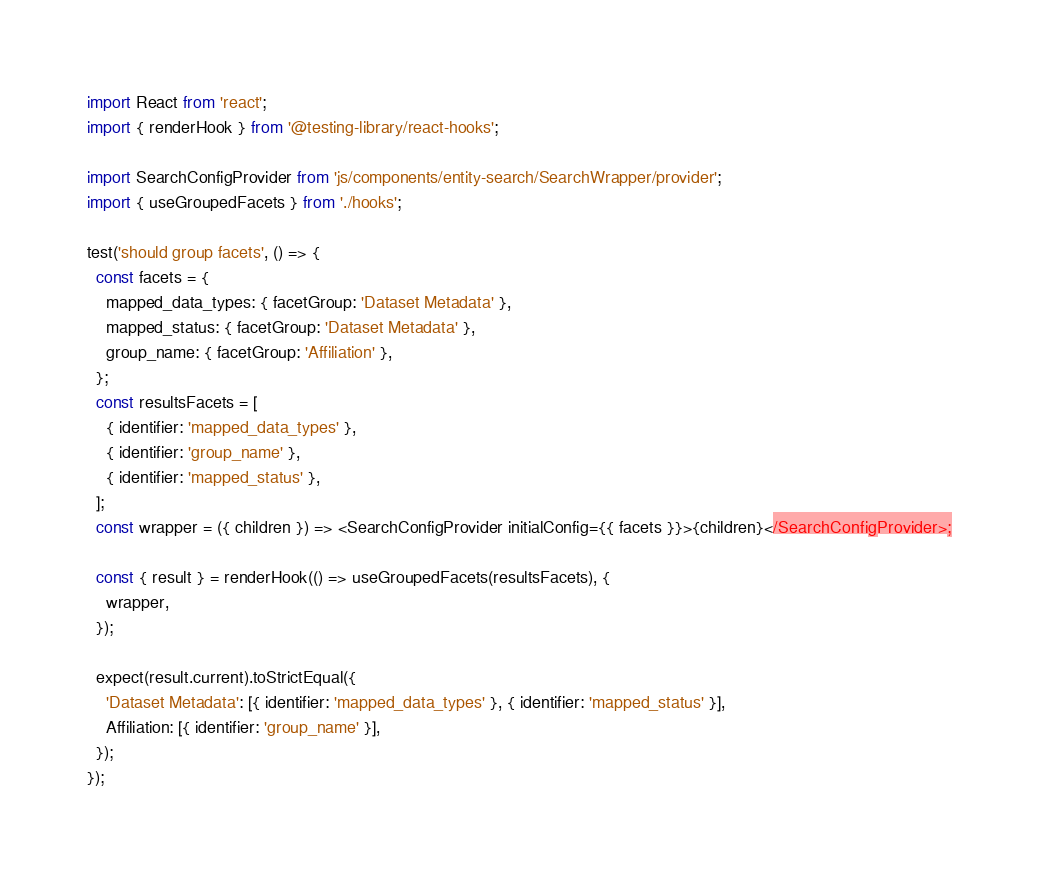Convert code to text. <code><loc_0><loc_0><loc_500><loc_500><_JavaScript_>import React from 'react';
import { renderHook } from '@testing-library/react-hooks';

import SearchConfigProvider from 'js/components/entity-search/SearchWrapper/provider';
import { useGroupedFacets } from './hooks';

test('should group facets', () => {
  const facets = {
    mapped_data_types: { facetGroup: 'Dataset Metadata' },
    mapped_status: { facetGroup: 'Dataset Metadata' },
    group_name: { facetGroup: 'Affiliation' },
  };
  const resultsFacets = [
    { identifier: 'mapped_data_types' },
    { identifier: 'group_name' },
    { identifier: 'mapped_status' },
  ];
  const wrapper = ({ children }) => <SearchConfigProvider initialConfig={{ facets }}>{children}</SearchConfigProvider>;

  const { result } = renderHook(() => useGroupedFacets(resultsFacets), {
    wrapper,
  });

  expect(result.current).toStrictEqual({
    'Dataset Metadata': [{ identifier: 'mapped_data_types' }, { identifier: 'mapped_status' }],
    Affiliation: [{ identifier: 'group_name' }],
  });
});
</code> 